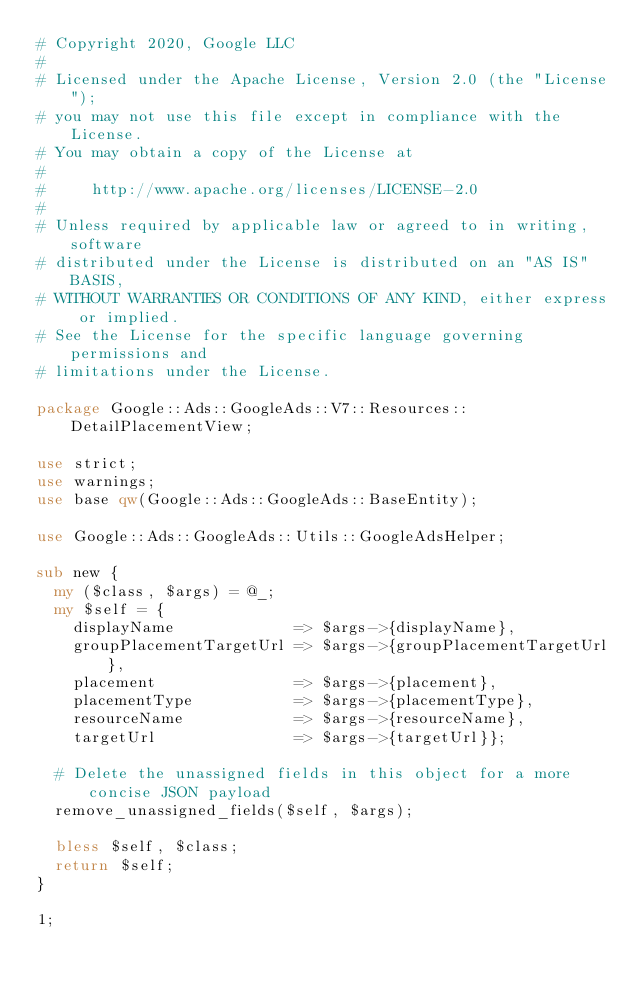<code> <loc_0><loc_0><loc_500><loc_500><_Perl_># Copyright 2020, Google LLC
#
# Licensed under the Apache License, Version 2.0 (the "License");
# you may not use this file except in compliance with the License.
# You may obtain a copy of the License at
#
#     http://www.apache.org/licenses/LICENSE-2.0
#
# Unless required by applicable law or agreed to in writing, software
# distributed under the License is distributed on an "AS IS" BASIS,
# WITHOUT WARRANTIES OR CONDITIONS OF ANY KIND, either express or implied.
# See the License for the specific language governing permissions and
# limitations under the License.

package Google::Ads::GoogleAds::V7::Resources::DetailPlacementView;

use strict;
use warnings;
use base qw(Google::Ads::GoogleAds::BaseEntity);

use Google::Ads::GoogleAds::Utils::GoogleAdsHelper;

sub new {
  my ($class, $args) = @_;
  my $self = {
    displayName             => $args->{displayName},
    groupPlacementTargetUrl => $args->{groupPlacementTargetUrl},
    placement               => $args->{placement},
    placementType           => $args->{placementType},
    resourceName            => $args->{resourceName},
    targetUrl               => $args->{targetUrl}};

  # Delete the unassigned fields in this object for a more concise JSON payload
  remove_unassigned_fields($self, $args);

  bless $self, $class;
  return $self;
}

1;
</code> 